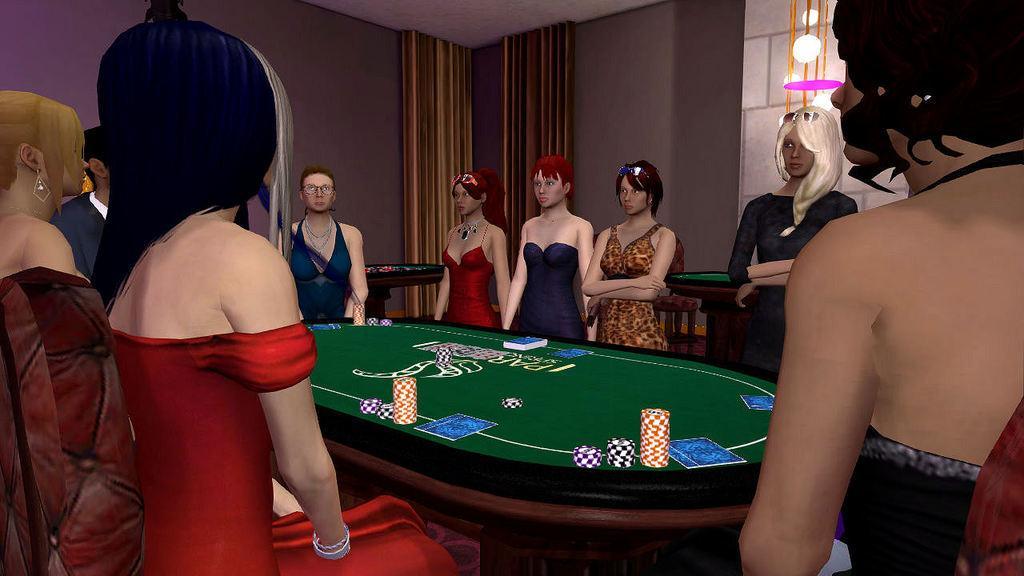Could you give a brief overview of what you see in this image? This picture shows an animated picture where people standing and we see a poker board and coins 